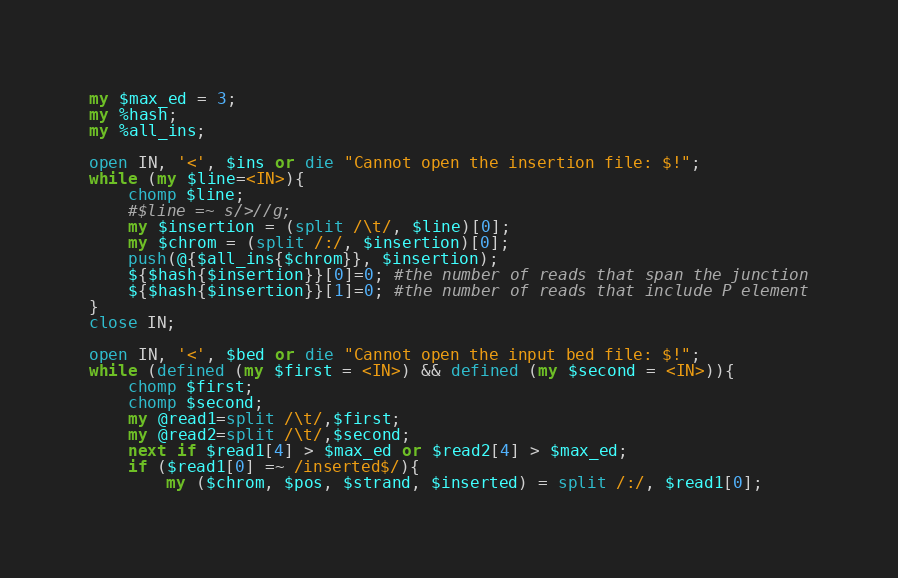Convert code to text. <code><loc_0><loc_0><loc_500><loc_500><_Perl_>my $max_ed = 3;
my %hash;
my %all_ins;

open IN, '<', $ins or die "Cannot open the insertion file: $!";
while (my $line=<IN>){
	chomp $line;
	#$line =~ s/>//g;
	my $insertion = (split /\t/, $line)[0];
	my $chrom = (split /:/, $insertion)[0];
	push(@{$all_ins{$chrom}}, $insertion);
	${$hash{$insertion}}[0]=0; #the number of reads that span the junction
	${$hash{$insertion}}[1]=0; #the number of reads that include P element
}
close IN;

open IN, '<', $bed or die "Cannot open the input bed file: $!";
while (defined (my $first = <IN>) && defined (my $second = <IN>)){
    chomp $first;
	chomp $second;
	my @read1=split /\t/,$first;
	my @read2=split /\t/,$second;
	next if $read1[4] > $max_ed or $read2[4] > $max_ed;
	if ($read1[0] =~ /inserted$/){
		my ($chrom, $pos, $strand, $inserted) = split /:/, $read1[0];</code> 